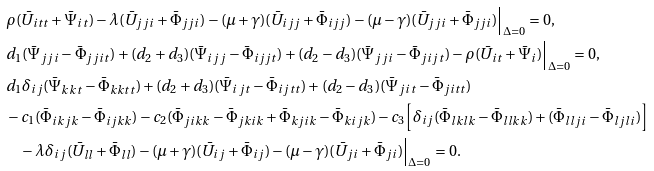Convert formula to latex. <formula><loc_0><loc_0><loc_500><loc_500>& \rho ( \bar { U } _ { i t t } + \bar { \Psi } _ { i t } ) - \lambda ( \bar { U } _ { j j i } + \bar { \Phi } _ { j j i } ) - ( \mu + \gamma ) ( \bar { U } _ { i j j } + \bar { \Phi } _ { i j j } ) - ( \mu - \gamma ) ( \bar { U } _ { j j i } + \bar { \Phi } _ { j j i } ) \Big | _ { \Delta = 0 } = 0 , \\ & d _ { 1 } ( \bar { \Psi } _ { j j i } - \bar { \Phi } _ { j j i t } ) + ( d _ { 2 } + d _ { 3 } ) ( \bar { \Psi } _ { i j j } - \bar { \Phi } _ { i j j t } ) + ( d _ { 2 } - d _ { 3 } ) ( \bar { \Psi } _ { j j i } - \bar { \Phi } _ { j i j t } ) - \rho ( \bar { U } _ { i t } + \bar { \Psi } _ { i } ) \Big | _ { \Delta = 0 } = 0 , \\ & d _ { 1 } \delta _ { i j } ( \bar { \Psi } _ { k k t } - \bar { \Phi } _ { k k t t } ) + ( d _ { 2 } + d _ { 3 } ) ( \bar { \Psi } _ { i j t } - \bar { \Phi } _ { i j t t } ) + ( d _ { 2 } - d _ { 3 } ) ( \bar { \Psi } _ { j i t } - \bar { \Phi } _ { j i t t } ) \\ & - c _ { 1 } ( \bar { \Phi } _ { i k j k } - \bar { \Phi } _ { i j k k } ) - c _ { 2 } ( \bar { \Phi } _ { j i k k } - \bar { \Phi } _ { j k i k } + \bar { \Phi } _ { k j i k } - \bar { \Phi } _ { k i j k } ) - c _ { 3 } \Big [ \delta _ { i j } ( \bar { \Phi } _ { l k l k } - \bar { \Phi } _ { l l k k } ) + ( \bar { \Phi } _ { l l j i } - \bar { \Phi } _ { l j l i } ) \Big ] \\ & \quad - \lambda \delta _ { i j } ( \bar { U } _ { l l } + \bar { \Phi } _ { l l } ) - ( \mu + \gamma ) ( \bar { U } _ { i j } + \bar { \Phi } _ { i j } ) - ( \mu - \gamma ) ( \bar { U } _ { j i } + \bar { \Phi } _ { j i } ) \Big | _ { \Delta = 0 } = 0 .</formula> 